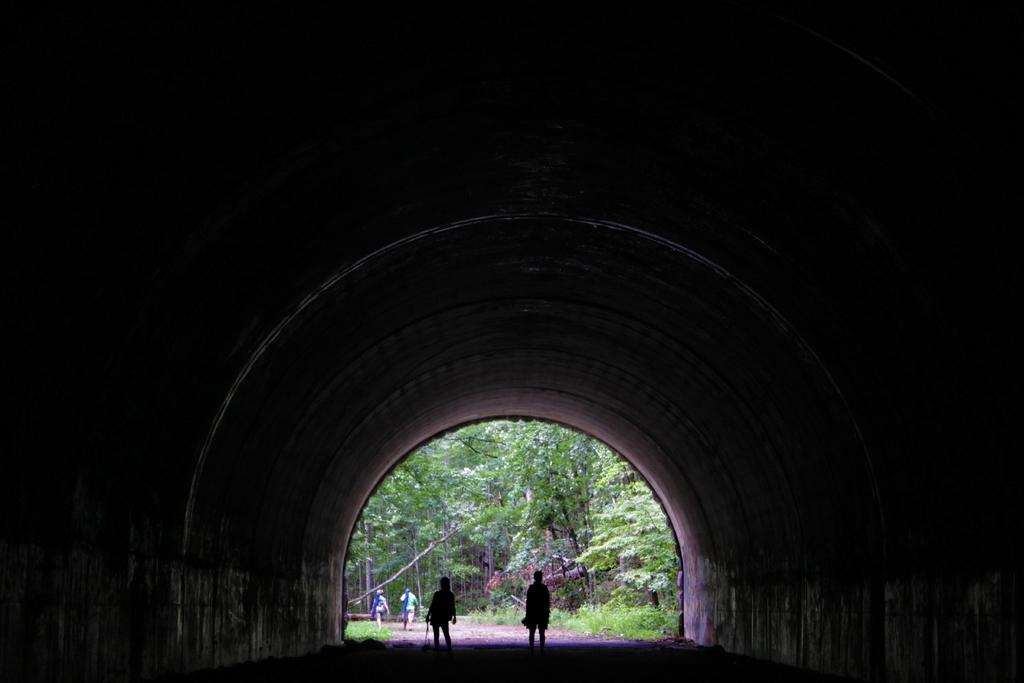What type of structure is present in the image? There is an arch in the image. What are the people in the image doing? The people in the image are walking. What are the people wearing? The people in the image are wearing clothes. What type of vegetation can be seen in the image? There are trees and grass in the image. Can you provide an example of a stitch used in the clothes worn by the people in the image? There is no information about the specific stitch used in the clothes worn by the people in the image. 